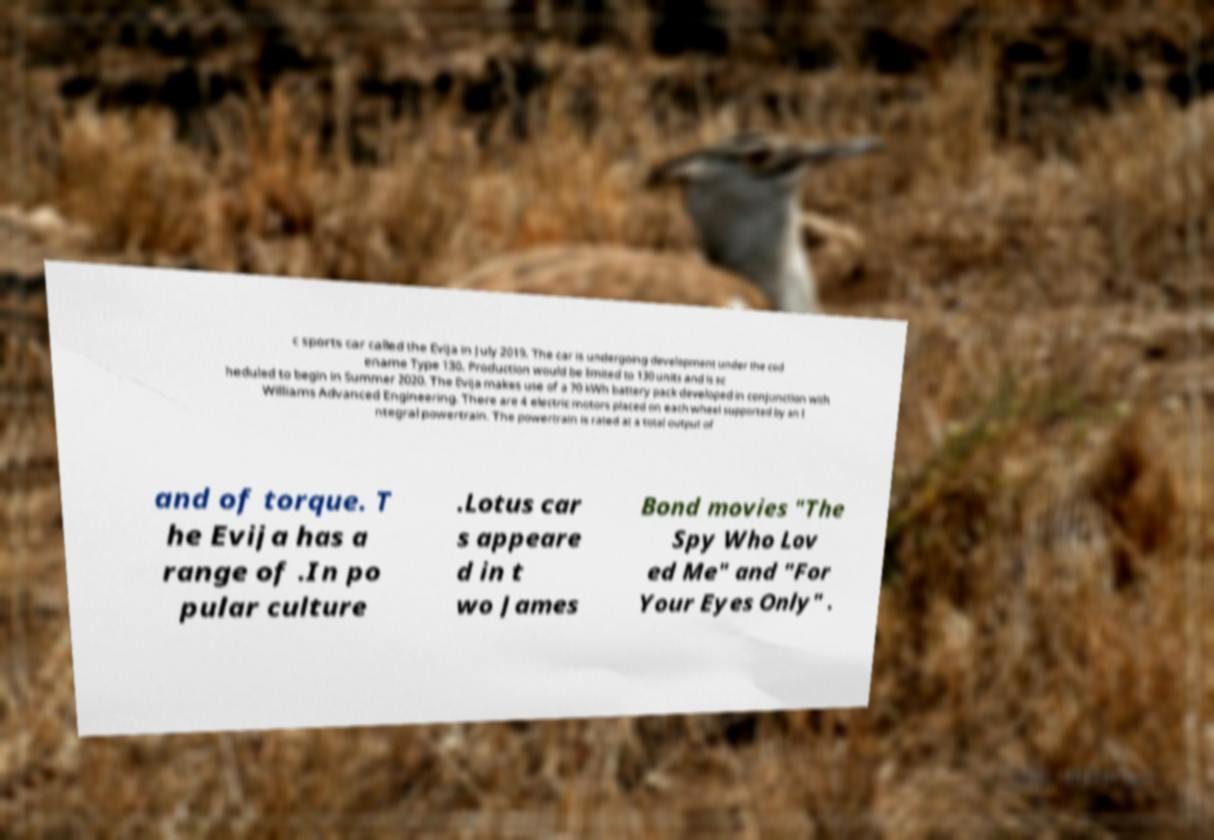There's text embedded in this image that I need extracted. Can you transcribe it verbatim? c sports car called the Evija in July 2019. The car is undergoing development under the cod ename Type 130. Production would be limited to 130 units and is sc heduled to begin in Summer 2020. The Evija makes use of a 70 kWh battery pack developed in conjunction with Williams Advanced Engineering. There are 4 electric motors placed on each wheel supported by an I ntegral powertrain. The powertrain is rated at a total output of and of torque. T he Evija has a range of .In po pular culture .Lotus car s appeare d in t wo James Bond movies "The Spy Who Lov ed Me" and "For Your Eyes Only" . 